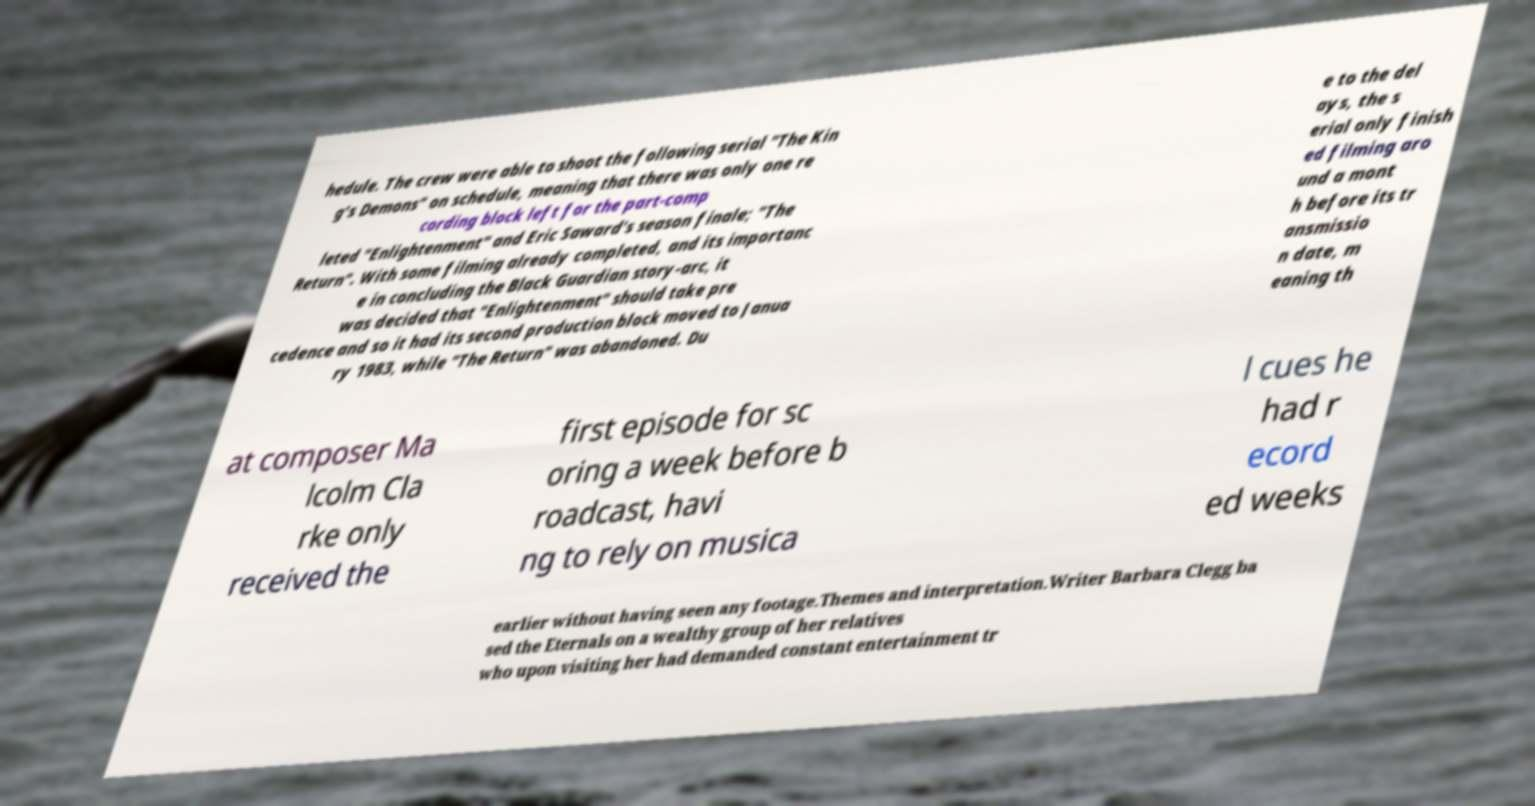Please identify and transcribe the text found in this image. hedule. The crew were able to shoot the following serial "The Kin g's Demons" on schedule, meaning that there was only one re cording block left for the part-comp leted "Enlightenment" and Eric Saward's season finale; "The Return". With some filming already completed, and its importanc e in concluding the Black Guardian story-arc, it was decided that "Enlightenment" should take pre cedence and so it had its second production block moved to Janua ry 1983, while "The Return" was abandoned. Du e to the del ays, the s erial only finish ed filming aro und a mont h before its tr ansmissio n date, m eaning th at composer Ma lcolm Cla rke only received the first episode for sc oring a week before b roadcast, havi ng to rely on musica l cues he had r ecord ed weeks earlier without having seen any footage.Themes and interpretation.Writer Barbara Clegg ba sed the Eternals on a wealthy group of her relatives who upon visiting her had demanded constant entertainment tr 